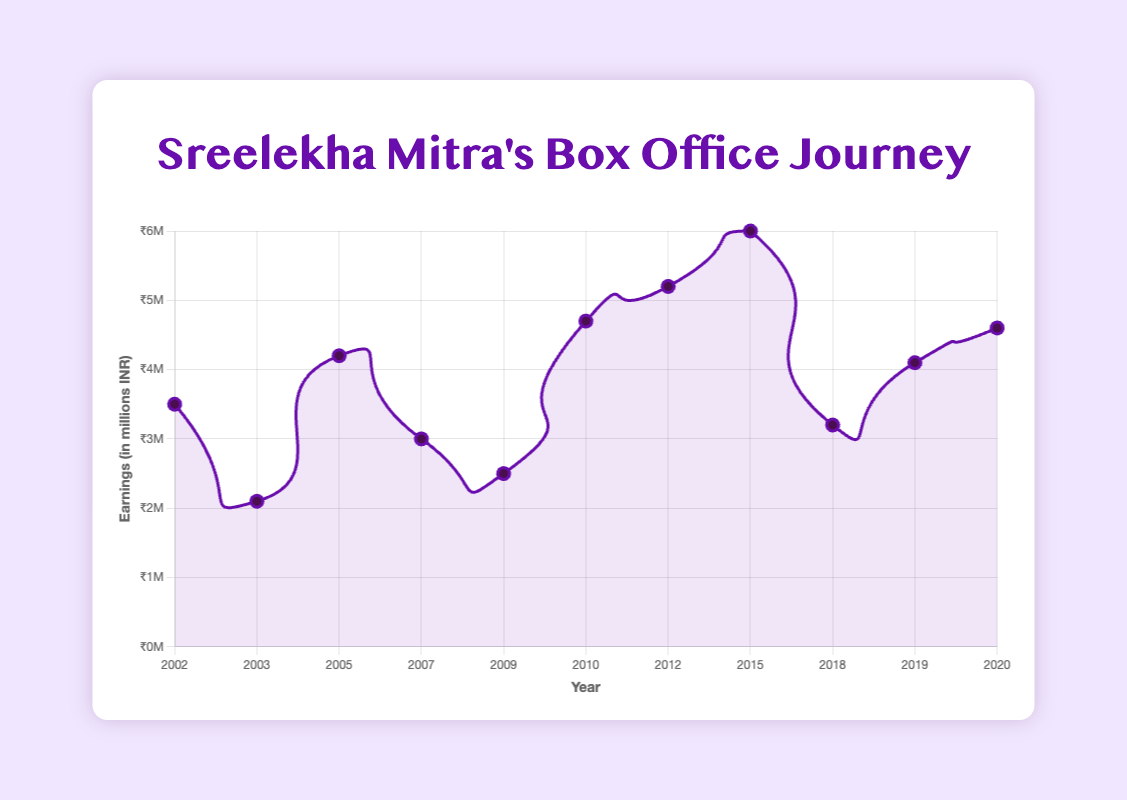Which film had the highest box office earnings? The film "Chotushkone" released in 2015 had the highest box office earnings, shown at the peak of the line chart at ₹6 million.
Answer: Chotushkone Between 2010 and 2012, which year had higher earnings, and how much higher was it? The year 2012 had higher earnings than 2010. In 2010, the earnings were ₹4.7 million, while in 2012, they were ₹5.2 million. The difference is ₹5.2M - ₹4.7M = ₹0.5M.
Answer: 2012, ₹0.5 million In which year did Sreelekha Mitra see a significant rise in earnings after a decline, and what was the difference in earnings? After a decline in 2003, there was a significant rise in 2005. The earnings increased from ₹2.1 million in 2003 to ₹4.2 million in 2005. The difference is ₹4.2M - ₹2.1M = ₹2.1M.
Answer: 2005, ₹2.1 million What is the average box office earnings from 2002 to 2020? Add all the earnings from 2002 to 2020 and divide by the number of years. The sum is 3.5 + 2.1 + 4.2 + 3 + 2.5 + 4.7 + 5.2 + 6 + 3.2 + 4.1 + 4.6 = 42.1. There are 11 data points, so the average is 42.1 / 11 = ₹3.83 million.
Answer: ₹3.83 million Which film's earnings were closest to ₹4 million? The film "Paromitar Ek Din" in 2005 had earnings of ₹4.2 million, which is the closest to ₹4 million.
Answer: Paromitar Ek Din How many films had earnings greater than ₹5 million? Examine the chart to identify points where the earnings are greater than ₹5 million. There are two films: "Aschorjo Prodip" (₹5.2 million) and "Chotushkone" (₹6 million).
Answer: 2 What is the total earnings in the decade from 2010 to 2020? Add the earnings from the films released between 2010 and 2020. The sum is 4.7 (2010) + 5.2 (2012) + 6 (2015) + 3.2 (2018) + 4.1 (2019) + 4.6 (2020) = ₹27.8 million.
Answer: ₹27.8 million Which year had the lowest box office earnings and what was the film? The lowest earnings were in 2003 with the film "Nandini," earning ₹2.1 million.
Answer: 2003, Nandini 